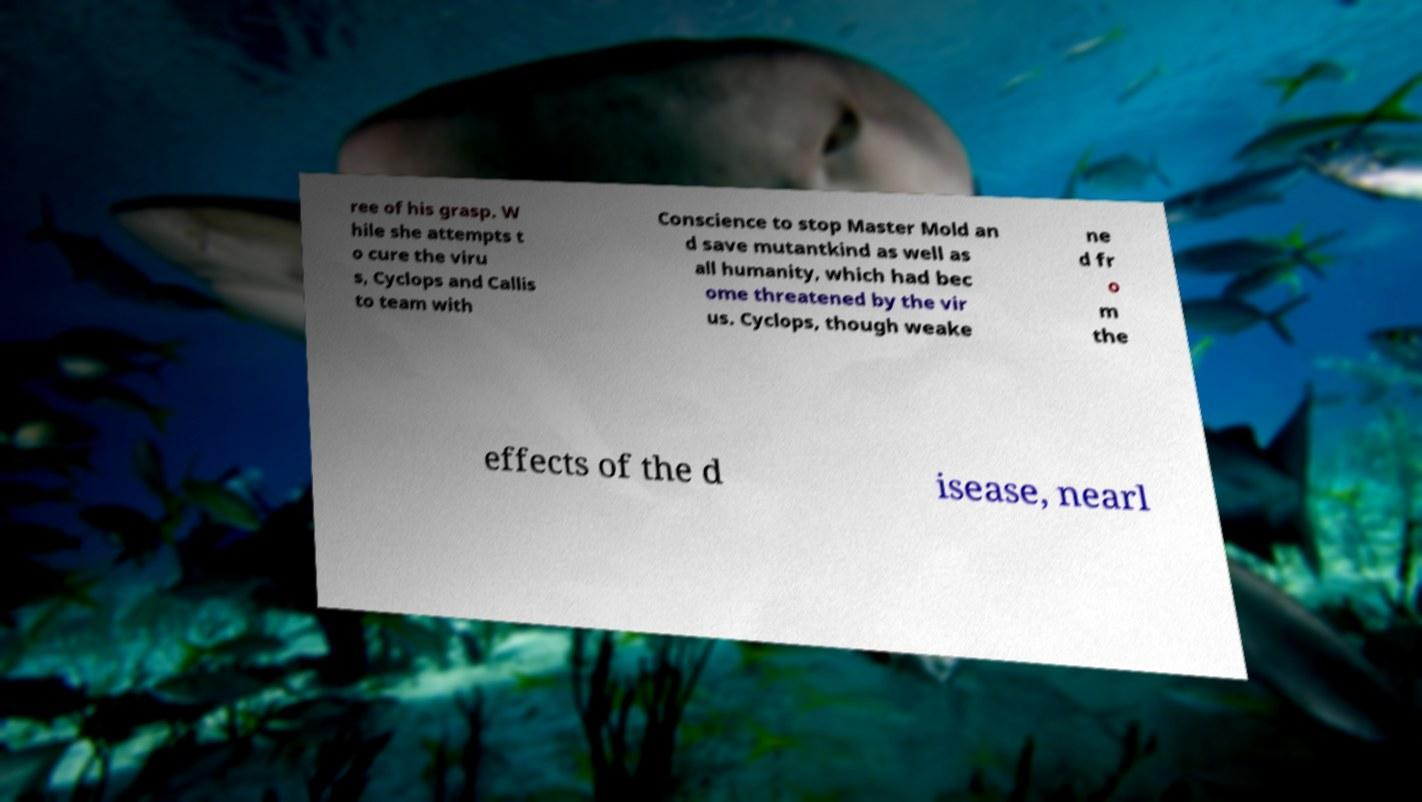Could you assist in decoding the text presented in this image and type it out clearly? ree of his grasp. W hile she attempts t o cure the viru s, Cyclops and Callis to team with Conscience to stop Master Mold an d save mutantkind as well as all humanity, which had bec ome threatened by the vir us. Cyclops, though weake ne d fr o m the effects of the d isease, nearl 